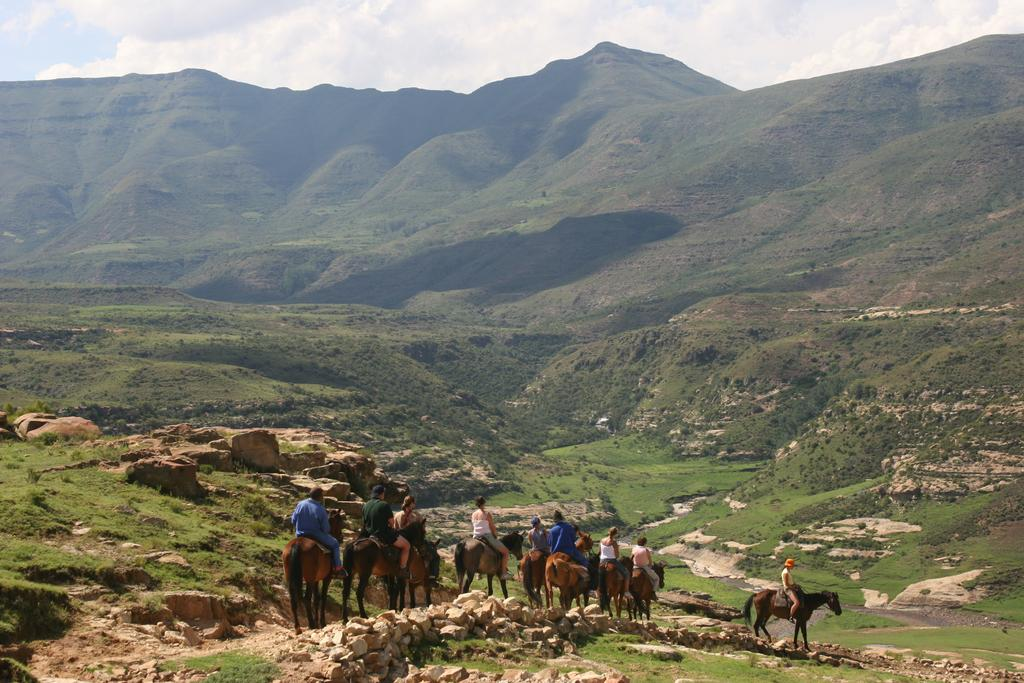What are the people doing in the image? The people are riding horses in the image. Where are the people located in the image? The people are at the bottom of the image. What can be seen in the background of the image? There are hills in the background of the image. What is the terrain like on the hills? The hills have grass on them. What is present at the bottom of the image? There are stones at the bottom of the image. How many mittens can be seen on the horses in the image? There are no mittens present in the image; the people are riding horses without any visible mittens. 